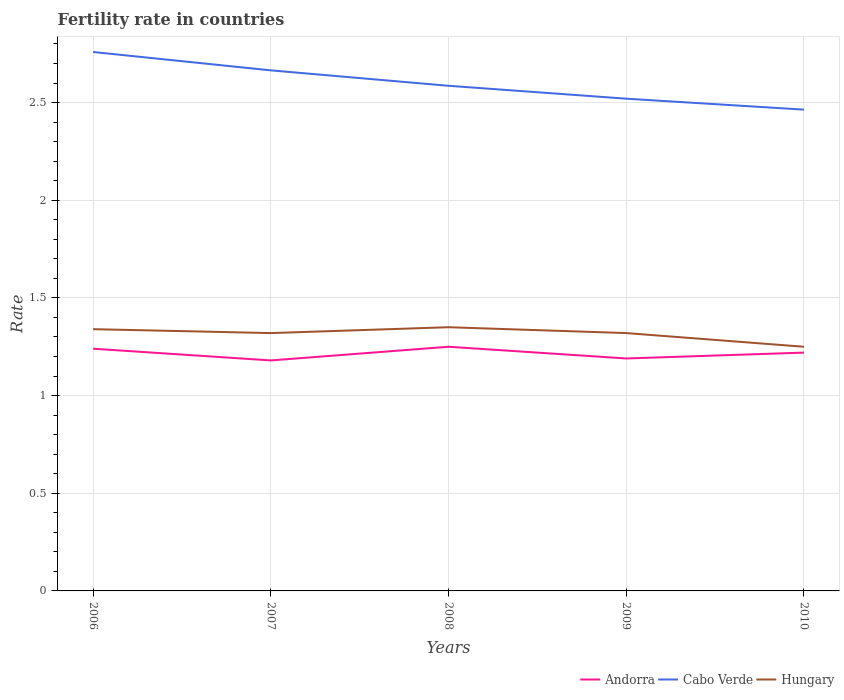How many different coloured lines are there?
Provide a short and direct response. 3. Does the line corresponding to Andorra intersect with the line corresponding to Hungary?
Offer a very short reply. No. Is the number of lines equal to the number of legend labels?
Ensure brevity in your answer.  Yes. In which year was the fertility rate in Hungary maximum?
Make the answer very short. 2010. What is the total fertility rate in Andorra in the graph?
Offer a very short reply. -0.03. What is the difference between the highest and the second highest fertility rate in Andorra?
Make the answer very short. 0.07. What is the difference between the highest and the lowest fertility rate in Cabo Verde?
Make the answer very short. 2. Is the fertility rate in Cabo Verde strictly greater than the fertility rate in Hungary over the years?
Give a very brief answer. No. How many years are there in the graph?
Ensure brevity in your answer.  5. Does the graph contain any zero values?
Your answer should be very brief. No. Does the graph contain grids?
Keep it short and to the point. Yes. How are the legend labels stacked?
Provide a short and direct response. Horizontal. What is the title of the graph?
Offer a very short reply. Fertility rate in countries. Does "French Polynesia" appear as one of the legend labels in the graph?
Your answer should be very brief. No. What is the label or title of the Y-axis?
Provide a short and direct response. Rate. What is the Rate of Andorra in 2006?
Make the answer very short. 1.24. What is the Rate of Cabo Verde in 2006?
Offer a terse response. 2.76. What is the Rate of Hungary in 2006?
Make the answer very short. 1.34. What is the Rate in Andorra in 2007?
Make the answer very short. 1.18. What is the Rate of Cabo Verde in 2007?
Keep it short and to the point. 2.67. What is the Rate of Hungary in 2007?
Ensure brevity in your answer.  1.32. What is the Rate of Cabo Verde in 2008?
Provide a short and direct response. 2.59. What is the Rate of Hungary in 2008?
Provide a succinct answer. 1.35. What is the Rate of Andorra in 2009?
Give a very brief answer. 1.19. What is the Rate in Cabo Verde in 2009?
Ensure brevity in your answer.  2.52. What is the Rate of Hungary in 2009?
Your answer should be compact. 1.32. What is the Rate of Andorra in 2010?
Make the answer very short. 1.22. What is the Rate in Cabo Verde in 2010?
Your answer should be very brief. 2.46. Across all years, what is the maximum Rate of Cabo Verde?
Your answer should be very brief. 2.76. Across all years, what is the maximum Rate of Hungary?
Ensure brevity in your answer.  1.35. Across all years, what is the minimum Rate in Andorra?
Offer a terse response. 1.18. Across all years, what is the minimum Rate of Cabo Verde?
Your response must be concise. 2.46. What is the total Rate in Andorra in the graph?
Offer a very short reply. 6.08. What is the total Rate in Cabo Verde in the graph?
Your answer should be very brief. 12.99. What is the total Rate in Hungary in the graph?
Your answer should be very brief. 6.58. What is the difference between the Rate in Andorra in 2006 and that in 2007?
Provide a short and direct response. 0.06. What is the difference between the Rate in Cabo Verde in 2006 and that in 2007?
Provide a short and direct response. 0.09. What is the difference between the Rate in Hungary in 2006 and that in 2007?
Your answer should be very brief. 0.02. What is the difference between the Rate of Andorra in 2006 and that in 2008?
Your response must be concise. -0.01. What is the difference between the Rate in Cabo Verde in 2006 and that in 2008?
Provide a succinct answer. 0.17. What is the difference between the Rate in Hungary in 2006 and that in 2008?
Ensure brevity in your answer.  -0.01. What is the difference between the Rate in Cabo Verde in 2006 and that in 2009?
Your answer should be very brief. 0.24. What is the difference between the Rate in Hungary in 2006 and that in 2009?
Ensure brevity in your answer.  0.02. What is the difference between the Rate of Cabo Verde in 2006 and that in 2010?
Provide a short and direct response. 0.29. What is the difference between the Rate of Hungary in 2006 and that in 2010?
Give a very brief answer. 0.09. What is the difference between the Rate of Andorra in 2007 and that in 2008?
Ensure brevity in your answer.  -0.07. What is the difference between the Rate of Cabo Verde in 2007 and that in 2008?
Your answer should be very brief. 0.08. What is the difference between the Rate of Hungary in 2007 and that in 2008?
Provide a short and direct response. -0.03. What is the difference between the Rate in Andorra in 2007 and that in 2009?
Provide a short and direct response. -0.01. What is the difference between the Rate of Cabo Verde in 2007 and that in 2009?
Provide a short and direct response. 0.14. What is the difference between the Rate of Andorra in 2007 and that in 2010?
Offer a very short reply. -0.04. What is the difference between the Rate of Cabo Verde in 2007 and that in 2010?
Your answer should be compact. 0.2. What is the difference between the Rate in Hungary in 2007 and that in 2010?
Your answer should be very brief. 0.07. What is the difference between the Rate of Cabo Verde in 2008 and that in 2009?
Offer a very short reply. 0.07. What is the difference between the Rate of Andorra in 2008 and that in 2010?
Your response must be concise. 0.03. What is the difference between the Rate of Cabo Verde in 2008 and that in 2010?
Keep it short and to the point. 0.12. What is the difference between the Rate of Andorra in 2009 and that in 2010?
Offer a very short reply. -0.03. What is the difference between the Rate of Cabo Verde in 2009 and that in 2010?
Provide a short and direct response. 0.06. What is the difference between the Rate in Hungary in 2009 and that in 2010?
Provide a short and direct response. 0.07. What is the difference between the Rate in Andorra in 2006 and the Rate in Cabo Verde in 2007?
Make the answer very short. -1.43. What is the difference between the Rate in Andorra in 2006 and the Rate in Hungary in 2007?
Your response must be concise. -0.08. What is the difference between the Rate in Cabo Verde in 2006 and the Rate in Hungary in 2007?
Ensure brevity in your answer.  1.44. What is the difference between the Rate of Andorra in 2006 and the Rate of Cabo Verde in 2008?
Give a very brief answer. -1.35. What is the difference between the Rate of Andorra in 2006 and the Rate of Hungary in 2008?
Your answer should be very brief. -0.11. What is the difference between the Rate in Cabo Verde in 2006 and the Rate in Hungary in 2008?
Your answer should be very brief. 1.41. What is the difference between the Rate in Andorra in 2006 and the Rate in Cabo Verde in 2009?
Offer a very short reply. -1.28. What is the difference between the Rate of Andorra in 2006 and the Rate of Hungary in 2009?
Your answer should be very brief. -0.08. What is the difference between the Rate of Cabo Verde in 2006 and the Rate of Hungary in 2009?
Make the answer very short. 1.44. What is the difference between the Rate in Andorra in 2006 and the Rate in Cabo Verde in 2010?
Provide a short and direct response. -1.22. What is the difference between the Rate of Andorra in 2006 and the Rate of Hungary in 2010?
Provide a short and direct response. -0.01. What is the difference between the Rate in Cabo Verde in 2006 and the Rate in Hungary in 2010?
Your response must be concise. 1.51. What is the difference between the Rate of Andorra in 2007 and the Rate of Cabo Verde in 2008?
Ensure brevity in your answer.  -1.41. What is the difference between the Rate of Andorra in 2007 and the Rate of Hungary in 2008?
Make the answer very short. -0.17. What is the difference between the Rate of Cabo Verde in 2007 and the Rate of Hungary in 2008?
Make the answer very short. 1.31. What is the difference between the Rate in Andorra in 2007 and the Rate in Cabo Verde in 2009?
Your response must be concise. -1.34. What is the difference between the Rate of Andorra in 2007 and the Rate of Hungary in 2009?
Keep it short and to the point. -0.14. What is the difference between the Rate of Cabo Verde in 2007 and the Rate of Hungary in 2009?
Ensure brevity in your answer.  1.34. What is the difference between the Rate in Andorra in 2007 and the Rate in Cabo Verde in 2010?
Offer a very short reply. -1.28. What is the difference between the Rate in Andorra in 2007 and the Rate in Hungary in 2010?
Make the answer very short. -0.07. What is the difference between the Rate of Cabo Verde in 2007 and the Rate of Hungary in 2010?
Your response must be concise. 1.42. What is the difference between the Rate in Andorra in 2008 and the Rate in Cabo Verde in 2009?
Ensure brevity in your answer.  -1.27. What is the difference between the Rate of Andorra in 2008 and the Rate of Hungary in 2009?
Make the answer very short. -0.07. What is the difference between the Rate in Cabo Verde in 2008 and the Rate in Hungary in 2009?
Offer a terse response. 1.27. What is the difference between the Rate in Andorra in 2008 and the Rate in Cabo Verde in 2010?
Offer a very short reply. -1.21. What is the difference between the Rate in Cabo Verde in 2008 and the Rate in Hungary in 2010?
Provide a short and direct response. 1.34. What is the difference between the Rate in Andorra in 2009 and the Rate in Cabo Verde in 2010?
Make the answer very short. -1.27. What is the difference between the Rate in Andorra in 2009 and the Rate in Hungary in 2010?
Provide a short and direct response. -0.06. What is the difference between the Rate in Cabo Verde in 2009 and the Rate in Hungary in 2010?
Offer a very short reply. 1.27. What is the average Rate in Andorra per year?
Keep it short and to the point. 1.22. What is the average Rate in Cabo Verde per year?
Your response must be concise. 2.6. What is the average Rate of Hungary per year?
Give a very brief answer. 1.32. In the year 2006, what is the difference between the Rate in Andorra and Rate in Cabo Verde?
Give a very brief answer. -1.52. In the year 2006, what is the difference between the Rate in Andorra and Rate in Hungary?
Provide a succinct answer. -0.1. In the year 2006, what is the difference between the Rate in Cabo Verde and Rate in Hungary?
Keep it short and to the point. 1.42. In the year 2007, what is the difference between the Rate of Andorra and Rate of Cabo Verde?
Provide a succinct answer. -1.49. In the year 2007, what is the difference between the Rate in Andorra and Rate in Hungary?
Your answer should be compact. -0.14. In the year 2007, what is the difference between the Rate in Cabo Verde and Rate in Hungary?
Keep it short and to the point. 1.34. In the year 2008, what is the difference between the Rate of Andorra and Rate of Cabo Verde?
Provide a succinct answer. -1.34. In the year 2008, what is the difference between the Rate in Cabo Verde and Rate in Hungary?
Ensure brevity in your answer.  1.24. In the year 2009, what is the difference between the Rate in Andorra and Rate in Cabo Verde?
Offer a terse response. -1.33. In the year 2009, what is the difference between the Rate in Andorra and Rate in Hungary?
Your response must be concise. -0.13. In the year 2009, what is the difference between the Rate of Cabo Verde and Rate of Hungary?
Provide a succinct answer. 1.2. In the year 2010, what is the difference between the Rate in Andorra and Rate in Cabo Verde?
Your response must be concise. -1.24. In the year 2010, what is the difference between the Rate in Andorra and Rate in Hungary?
Make the answer very short. -0.03. In the year 2010, what is the difference between the Rate in Cabo Verde and Rate in Hungary?
Your answer should be compact. 1.21. What is the ratio of the Rate of Andorra in 2006 to that in 2007?
Your answer should be compact. 1.05. What is the ratio of the Rate in Cabo Verde in 2006 to that in 2007?
Your response must be concise. 1.04. What is the ratio of the Rate of Hungary in 2006 to that in 2007?
Keep it short and to the point. 1.02. What is the ratio of the Rate of Cabo Verde in 2006 to that in 2008?
Provide a succinct answer. 1.07. What is the ratio of the Rate in Hungary in 2006 to that in 2008?
Make the answer very short. 0.99. What is the ratio of the Rate in Andorra in 2006 to that in 2009?
Provide a succinct answer. 1.04. What is the ratio of the Rate of Cabo Verde in 2006 to that in 2009?
Your response must be concise. 1.09. What is the ratio of the Rate of Hungary in 2006 to that in 2009?
Provide a short and direct response. 1.02. What is the ratio of the Rate of Andorra in 2006 to that in 2010?
Give a very brief answer. 1.02. What is the ratio of the Rate in Cabo Verde in 2006 to that in 2010?
Your response must be concise. 1.12. What is the ratio of the Rate in Hungary in 2006 to that in 2010?
Provide a succinct answer. 1.07. What is the ratio of the Rate of Andorra in 2007 to that in 2008?
Keep it short and to the point. 0.94. What is the ratio of the Rate in Cabo Verde in 2007 to that in 2008?
Your answer should be very brief. 1.03. What is the ratio of the Rate in Hungary in 2007 to that in 2008?
Give a very brief answer. 0.98. What is the ratio of the Rate in Andorra in 2007 to that in 2009?
Offer a terse response. 0.99. What is the ratio of the Rate of Cabo Verde in 2007 to that in 2009?
Provide a succinct answer. 1.06. What is the ratio of the Rate of Andorra in 2007 to that in 2010?
Offer a very short reply. 0.97. What is the ratio of the Rate of Cabo Verde in 2007 to that in 2010?
Provide a short and direct response. 1.08. What is the ratio of the Rate of Hungary in 2007 to that in 2010?
Keep it short and to the point. 1.06. What is the ratio of the Rate of Andorra in 2008 to that in 2009?
Offer a terse response. 1.05. What is the ratio of the Rate in Cabo Verde in 2008 to that in 2009?
Offer a terse response. 1.03. What is the ratio of the Rate of Hungary in 2008 to that in 2009?
Keep it short and to the point. 1.02. What is the ratio of the Rate in Andorra in 2008 to that in 2010?
Offer a terse response. 1.02. What is the ratio of the Rate in Cabo Verde in 2008 to that in 2010?
Your answer should be very brief. 1.05. What is the ratio of the Rate in Hungary in 2008 to that in 2010?
Offer a very short reply. 1.08. What is the ratio of the Rate of Andorra in 2009 to that in 2010?
Your response must be concise. 0.98. What is the ratio of the Rate of Cabo Verde in 2009 to that in 2010?
Your response must be concise. 1.02. What is the ratio of the Rate in Hungary in 2009 to that in 2010?
Your answer should be compact. 1.06. What is the difference between the highest and the second highest Rate of Andorra?
Your answer should be compact. 0.01. What is the difference between the highest and the second highest Rate in Cabo Verde?
Your answer should be compact. 0.09. What is the difference between the highest and the second highest Rate of Hungary?
Make the answer very short. 0.01. What is the difference between the highest and the lowest Rate of Andorra?
Your response must be concise. 0.07. What is the difference between the highest and the lowest Rate of Cabo Verde?
Make the answer very short. 0.29. What is the difference between the highest and the lowest Rate in Hungary?
Make the answer very short. 0.1. 